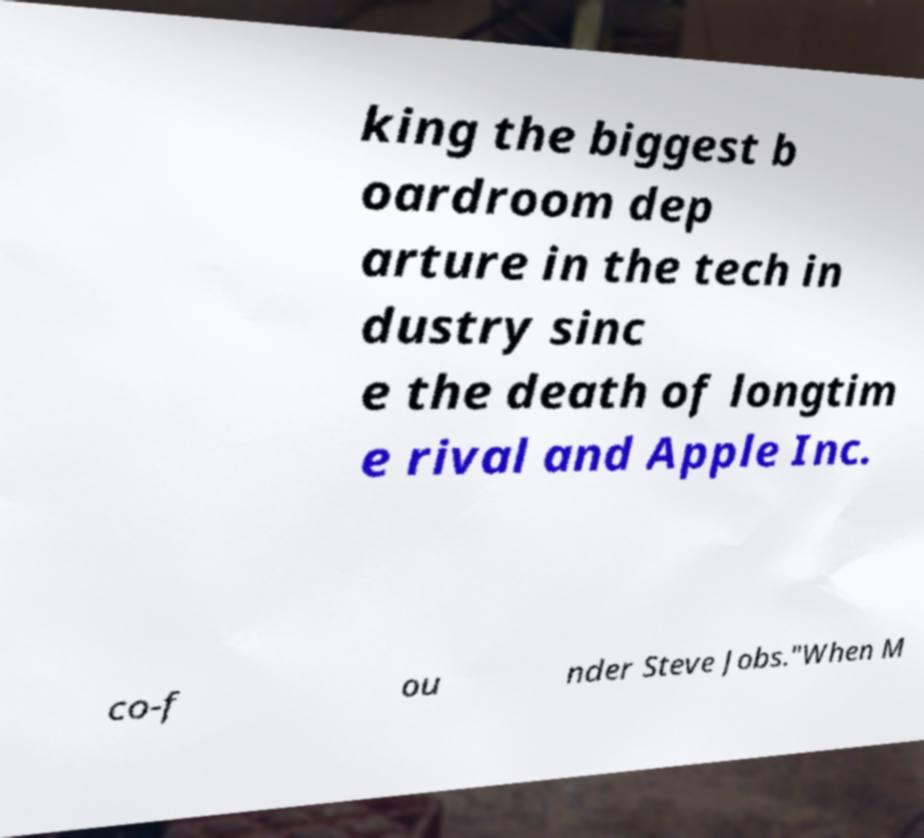Please read and relay the text visible in this image. What does it say? king the biggest b oardroom dep arture in the tech in dustry sinc e the death of longtim e rival and Apple Inc. co-f ou nder Steve Jobs."When M 